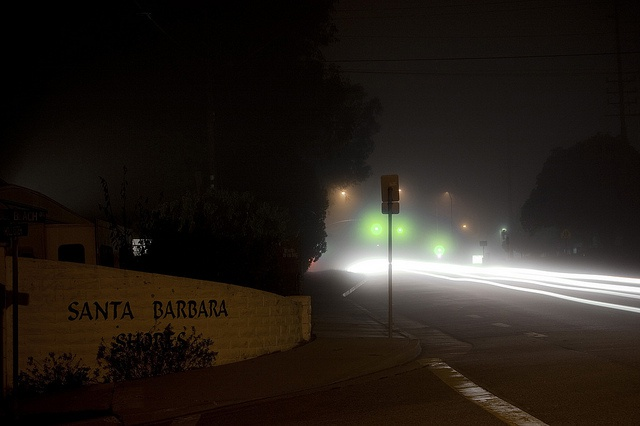Describe the objects in this image and their specific colors. I can see a traffic light in black and gray tones in this image. 